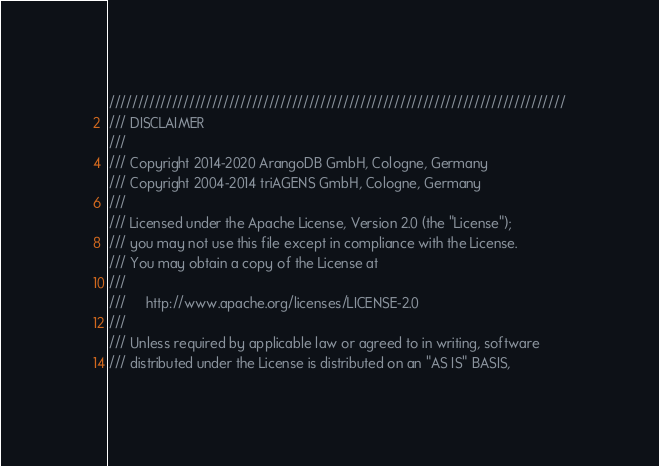<code> <loc_0><loc_0><loc_500><loc_500><_C++_>////////////////////////////////////////////////////////////////////////////////
/// DISCLAIMER
///
/// Copyright 2014-2020 ArangoDB GmbH, Cologne, Germany
/// Copyright 2004-2014 triAGENS GmbH, Cologne, Germany
///
/// Licensed under the Apache License, Version 2.0 (the "License");
/// you may not use this file except in compliance with the License.
/// You may obtain a copy of the License at
///
///     http://www.apache.org/licenses/LICENSE-2.0
///
/// Unless required by applicable law or agreed to in writing, software
/// distributed under the License is distributed on an "AS IS" BASIS,</code> 